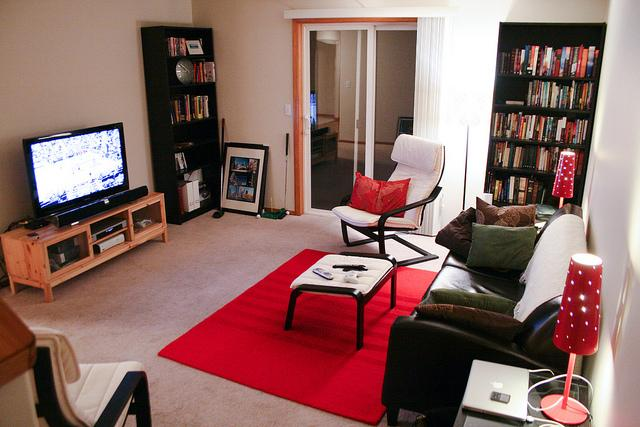What is the black couch against the wall made out of? leather 